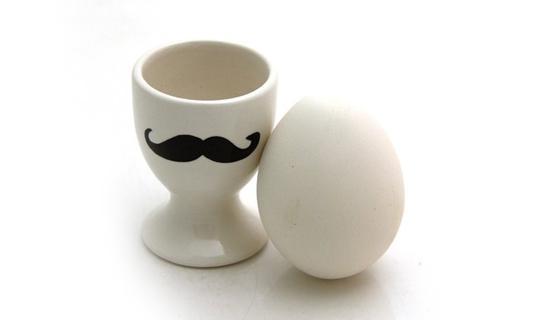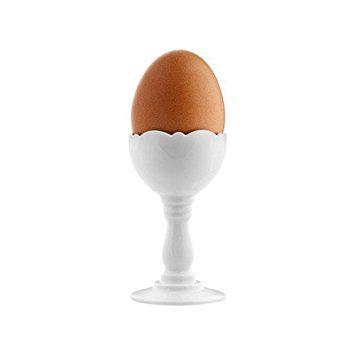The first image is the image on the left, the second image is the image on the right. Evaluate the accuracy of this statement regarding the images: "The egg in the image on the right is brown.". Is it true? Answer yes or no. Yes. 